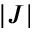Convert formula to latex. <formula><loc_0><loc_0><loc_500><loc_500>| J |</formula> 